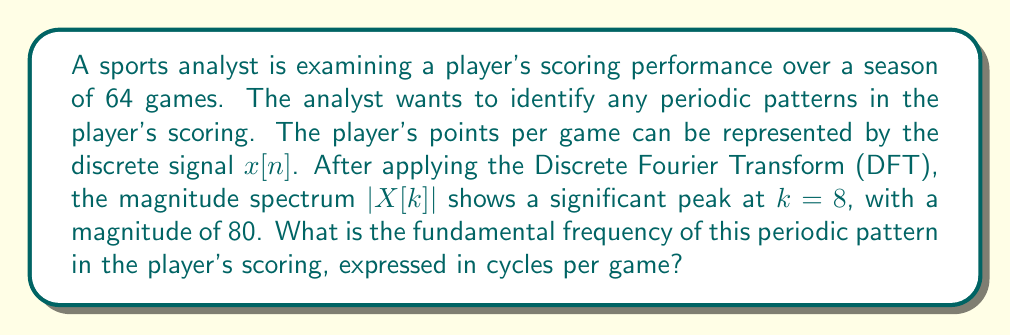Could you help me with this problem? To solve this problem, we need to understand the relationship between the DFT and the original signal's frequency components. Let's break it down step-by-step:

1. The DFT of a discrete signal of length N is given by:

   $$X[k] = \sum_{n=0}^{N-1} x[n] e^{-j2\pi kn/N}$$

   where $k = 0, 1, ..., N-1$.

2. In this case, we have N = 64 games.

3. The frequency resolution of the DFT is given by:

   $$\Delta f = \frac{f_s}{N}$$

   where $f_s$ is the sampling frequency (in this case, 1 game, as we have one data point per game).

4. Therefore, the frequency resolution is:

   $$\Delta f = \frac{1 \text{ game}^{-1}}{64} = \frac{1}{64} \text{ cycles/game}$$

5. The peak in the magnitude spectrum occurs at $k=8$. To find the corresponding frequency, we multiply the index by the frequency resolution:

   $$f = k \cdot \Delta f = 8 \cdot \frac{1}{64} = \frac{1}{8} \text{ cycles/game}$$

This frequency represents the fundamental frequency of the periodic pattern in the player's scoring performance.
Answer: $\frac{1}{8}$ cycles/game 